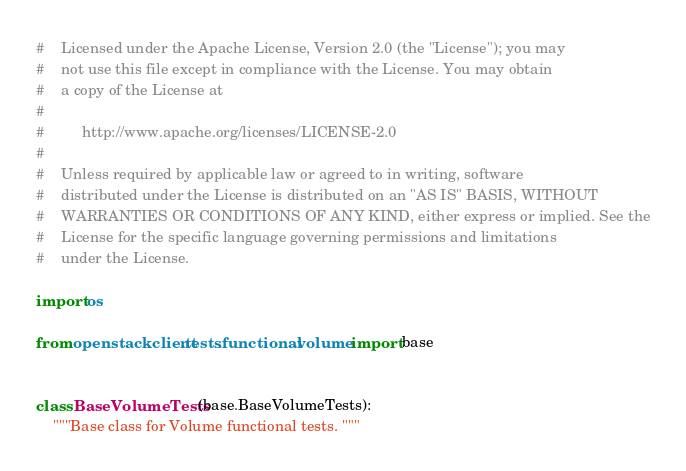<code> <loc_0><loc_0><loc_500><loc_500><_Python_>#    Licensed under the Apache License, Version 2.0 (the "License"); you may
#    not use this file except in compliance with the License. You may obtain
#    a copy of the License at
#
#         http://www.apache.org/licenses/LICENSE-2.0
#
#    Unless required by applicable law or agreed to in writing, software
#    distributed under the License is distributed on an "AS IS" BASIS, WITHOUT
#    WARRANTIES OR CONDITIONS OF ANY KIND, either express or implied. See the
#    License for the specific language governing permissions and limitations
#    under the License.

import os

from openstackclient.tests.functional.volume import base


class BaseVolumeTests(base.BaseVolumeTests):
    """Base class for Volume functional tests. """
</code> 